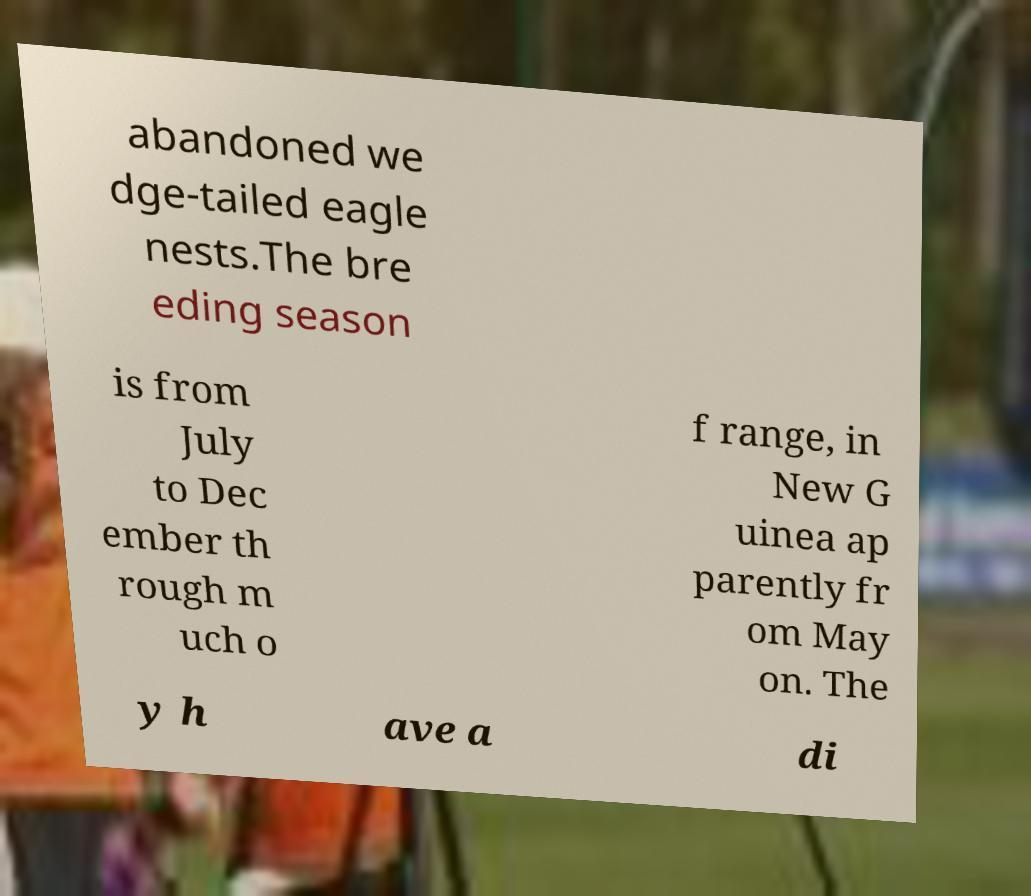I need the written content from this picture converted into text. Can you do that? abandoned we dge-tailed eagle nests.The bre eding season is from July to Dec ember th rough m uch o f range, in New G uinea ap parently fr om May on. The y h ave a di 